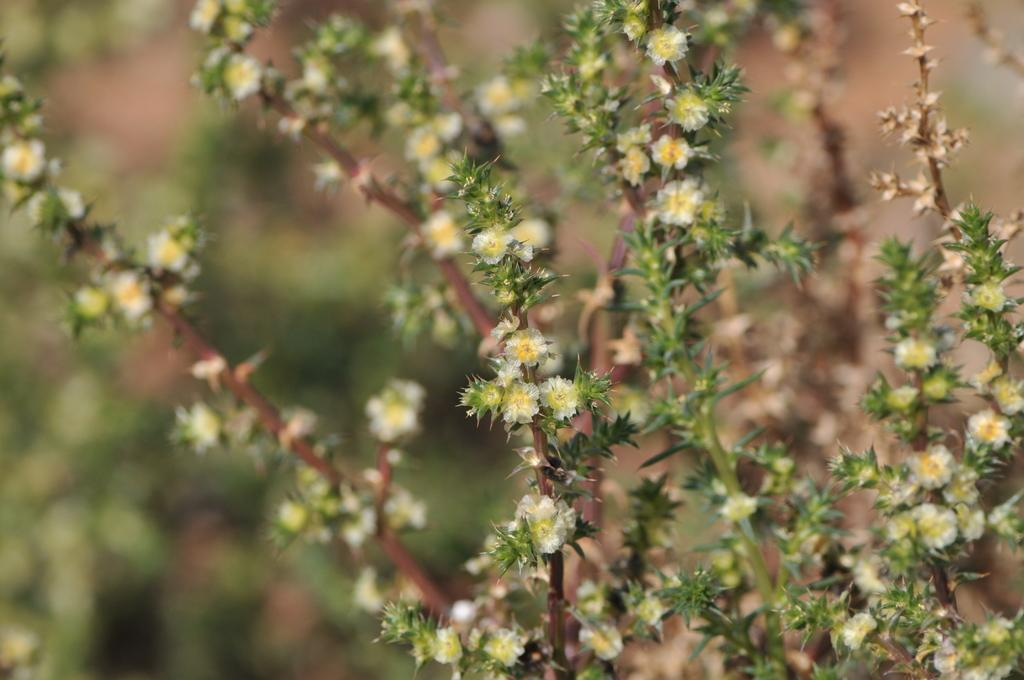What type of plants can be seen in the image? There are plants with flowers and plants with buds in the image. Can you describe the plants in the background? The plants in the background are not specified in the facts, but we know there are plants with flowers and plants with buds. How is the image quality? The image is blurred. What type of apples are being carried by the group in the image? There is no group or apples present in the image; it features plants with flowers and plants with buds. 